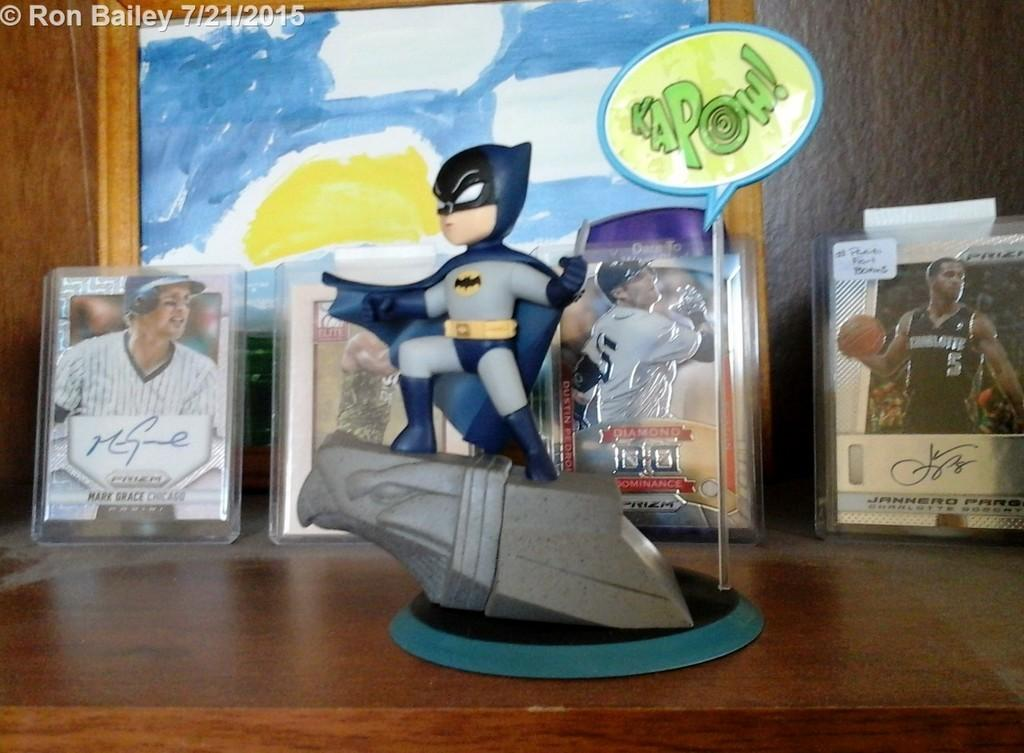What is the main subject of the image? There is a doll in the image. What can be seen in the background of the image? There are frames and photographs in the background of the image. What type of furniture is at the bottom of the image? There is a wooden desk at the bottom of the image. What type of wren is perched on the doll's shoulder in the image? There is no wren present in the image; it only features a doll and the background elements mentioned earlier. 